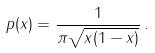Convert formula to latex. <formula><loc_0><loc_0><loc_500><loc_500>p ( x ) = \frac { 1 } { \pi \sqrt { x ( 1 - x ) } } \, .</formula> 